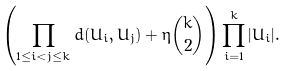<formula> <loc_0><loc_0><loc_500><loc_500>\left ( \prod _ { 1 \leq i < j \leq k } d ( U _ { i } , U _ { j } ) + \eta \binom { k } { 2 } \right ) \prod _ { i = 1 } ^ { k } | U _ { i } | .</formula> 